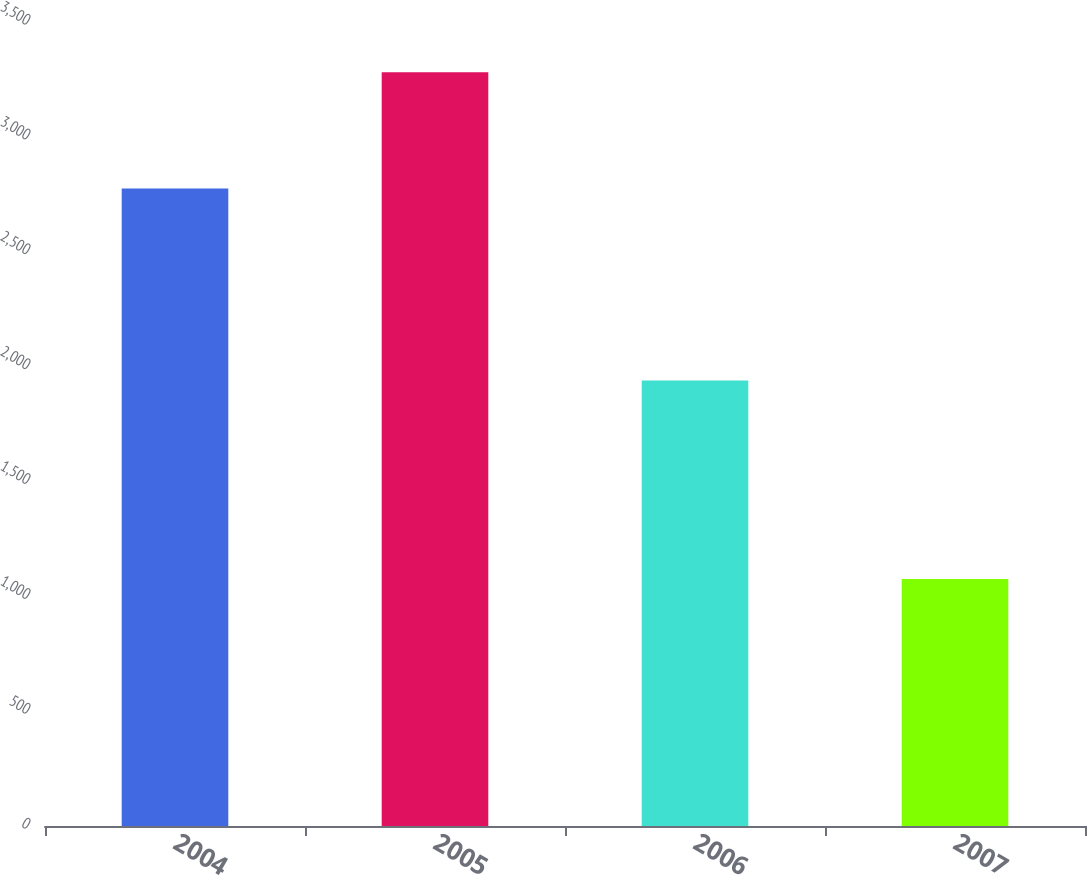<chart> <loc_0><loc_0><loc_500><loc_500><bar_chart><fcel>2004<fcel>2005<fcel>2006<fcel>2007<nl><fcel>2775<fcel>3281<fcel>1939<fcel>1075<nl></chart> 